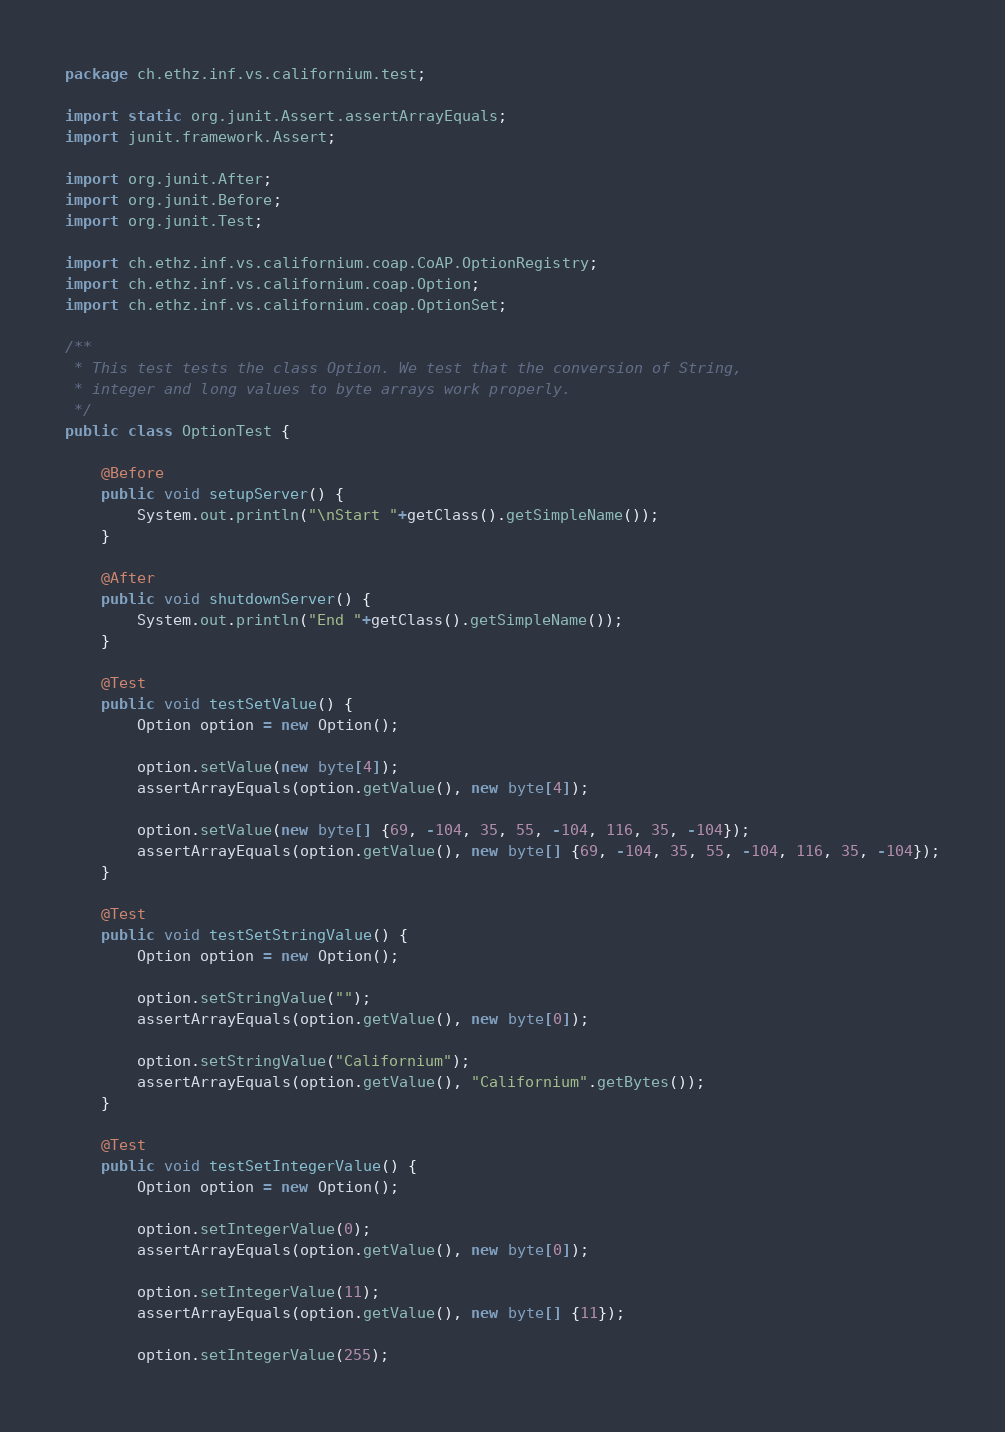<code> <loc_0><loc_0><loc_500><loc_500><_Java_>package ch.ethz.inf.vs.californium.test;

import static org.junit.Assert.assertArrayEquals;
import junit.framework.Assert;

import org.junit.After;
import org.junit.Before;
import org.junit.Test;

import ch.ethz.inf.vs.californium.coap.CoAP.OptionRegistry;
import ch.ethz.inf.vs.californium.coap.Option;
import ch.ethz.inf.vs.californium.coap.OptionSet;

/**
 * This test tests the class Option. We test that the conversion of String,
 * integer and long values to byte arrays work properly.
 */
public class OptionTest {

	@Before
	public void setupServer() {
		System.out.println("\nStart "+getClass().getSimpleName());
	}
	
	@After
	public void shutdownServer() {
		System.out.println("End "+getClass().getSimpleName());
	}
	
	@Test
	public void testSetValue() {
		Option option = new Option();

		option.setValue(new byte[4]);
		assertArrayEquals(option.getValue(), new byte[4]);
		
		option.setValue(new byte[] {69, -104, 35, 55, -104, 116, 35, -104});
		assertArrayEquals(option.getValue(), new byte[] {69, -104, 35, 55, -104, 116, 35, -104});
	}
	
	@Test
	public void testSetStringValue() {
		Option option = new Option();
		
		option.setStringValue("");
		assertArrayEquals(option.getValue(), new byte[0]);

		option.setStringValue("Californium");
		assertArrayEquals(option.getValue(), "Californium".getBytes());
	}
	
	@Test
	public void testSetIntegerValue() {
		Option option = new Option();

		option.setIntegerValue(0);
		assertArrayEquals(option.getValue(), new byte[0]);
		
		option.setIntegerValue(11);
		assertArrayEquals(option.getValue(), new byte[] {11});
		
		option.setIntegerValue(255);</code> 